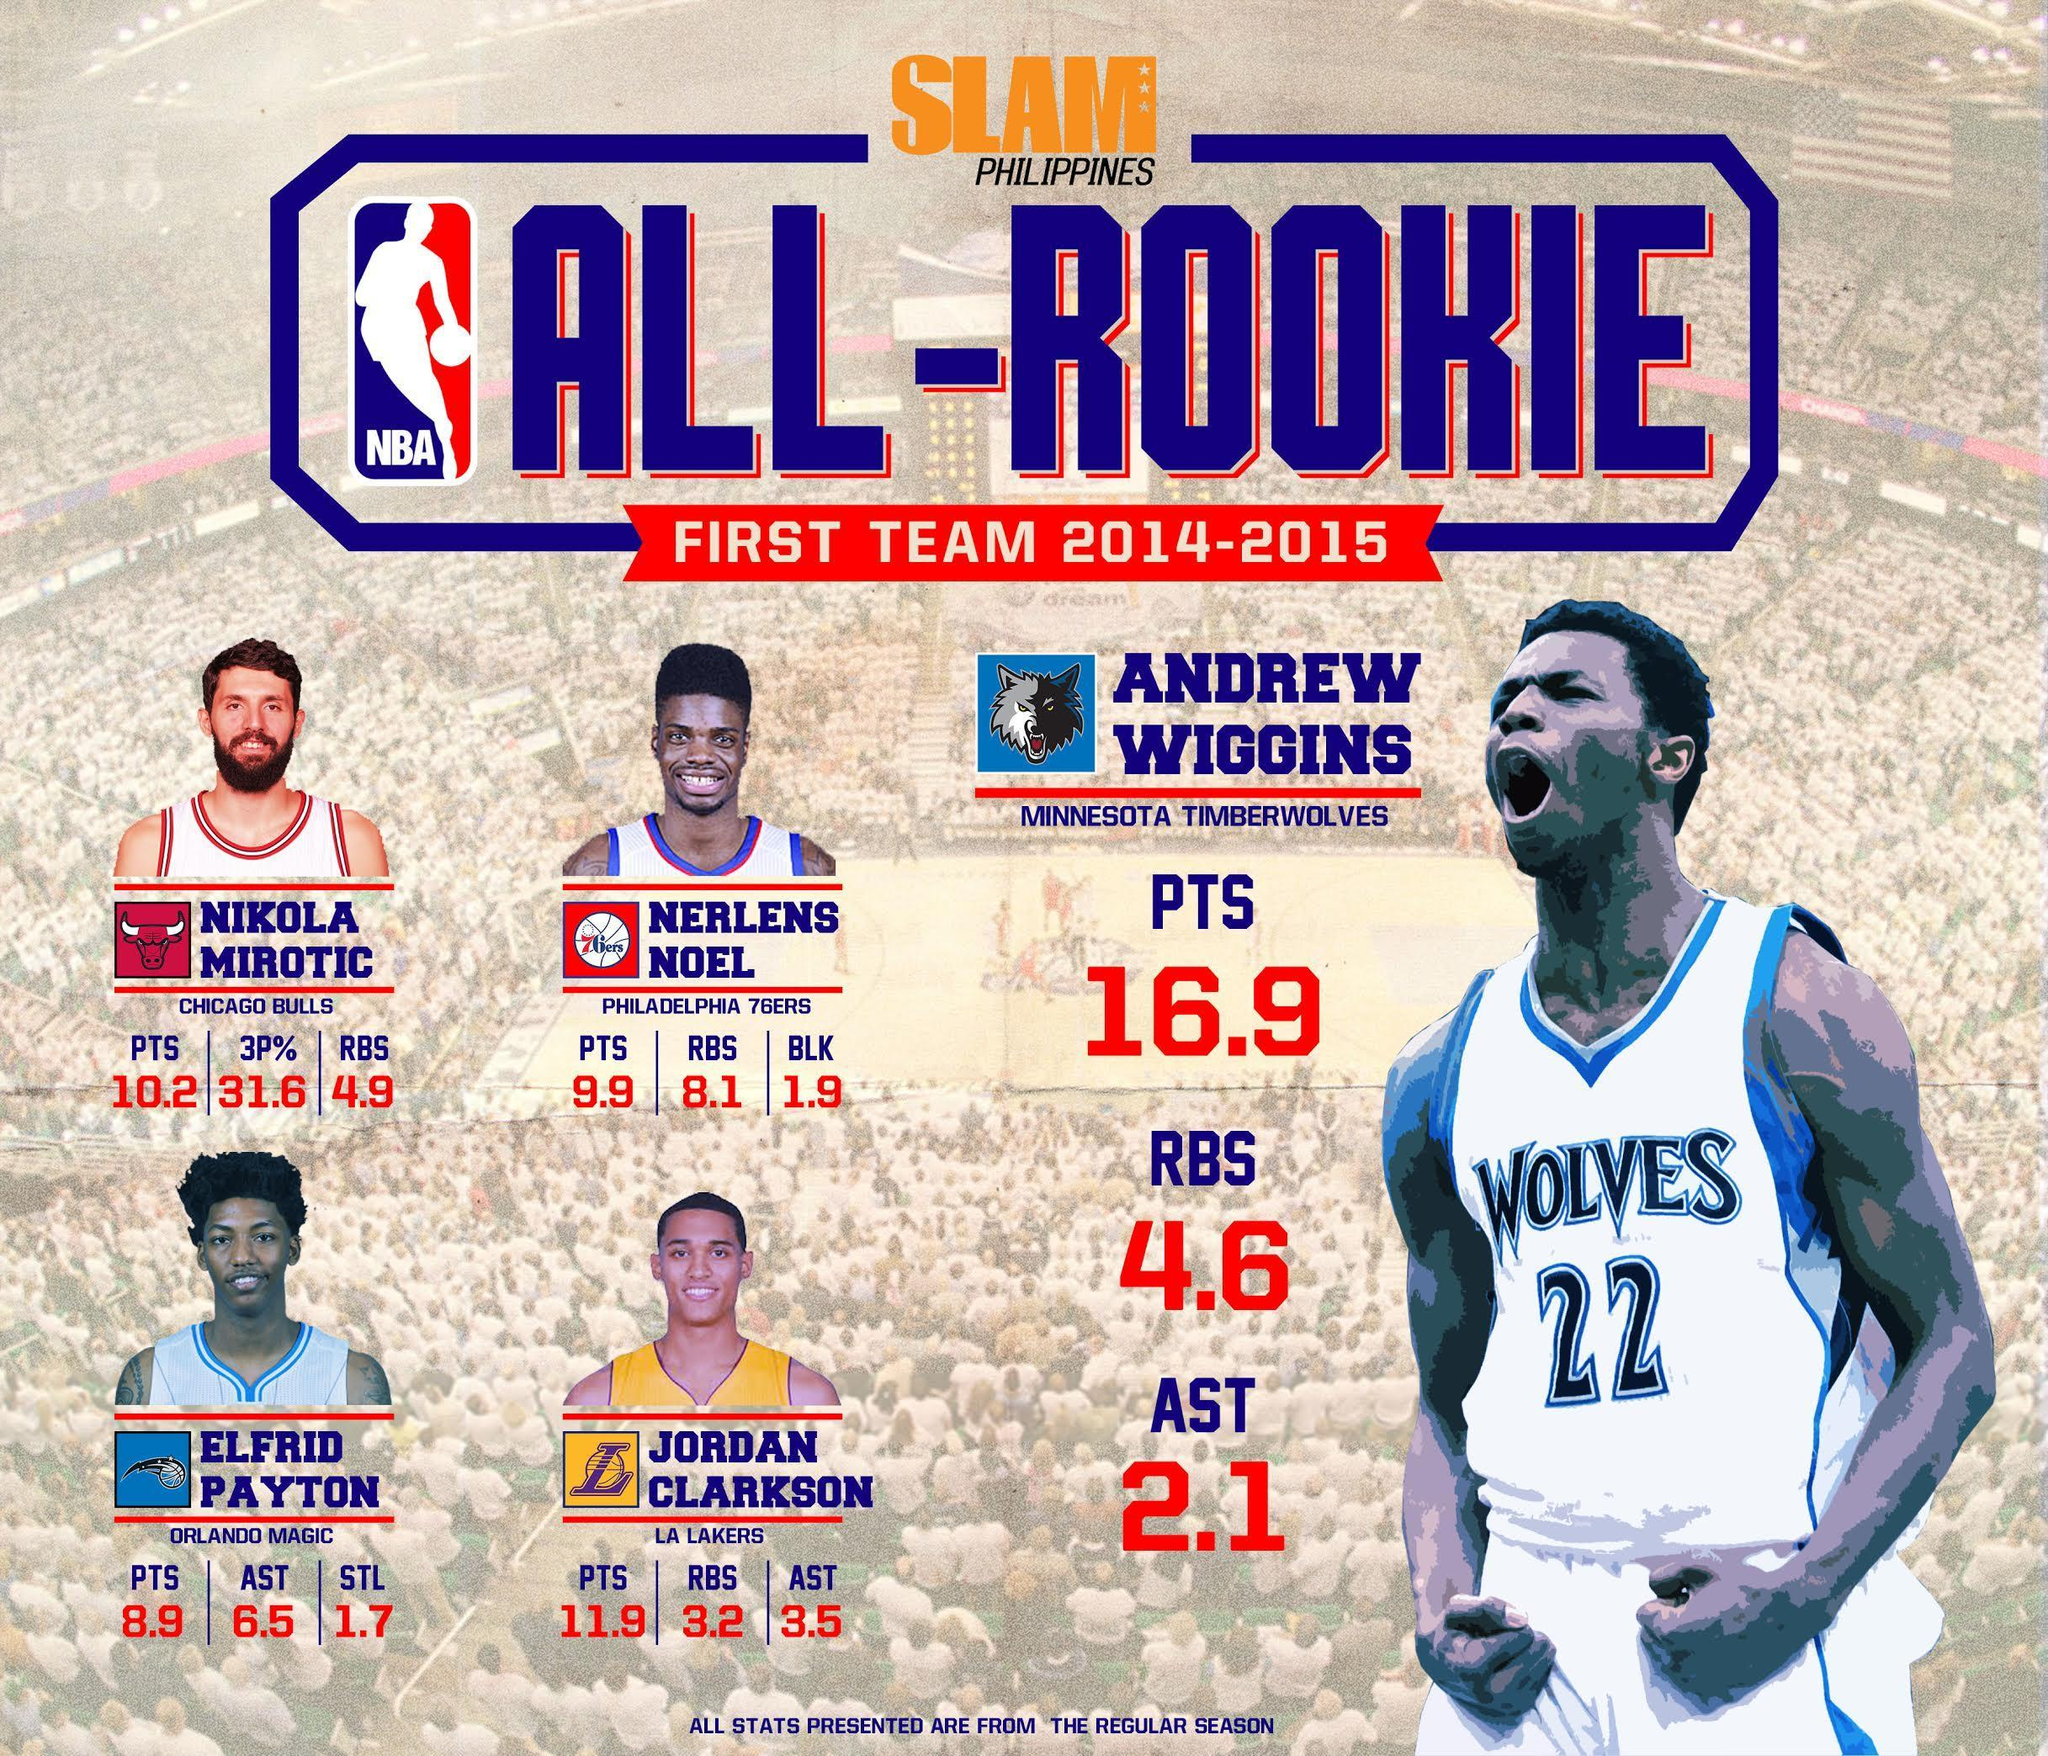Which basketball team does Andrew Wiggins play for during 2014-2015 NBA season?
Answer the question with a short phrase. MINNESOTA TIMBERWOLVES What is the average rebounds by Nerlens Noel during 2014-2015 NBA season? 8.1 Which player has three-point field goal percentage value of 31.6 during 2014-2015 NBA season? NIKOLA MIROTIC What is the average assists by Elfrid Payton during 2014-2015 NBA season? 6.5 What is the jersey number of Andrew Wiggins? 22 What is the average points scored by Nikola Mirotic during 2014-2015 NBA season? 10.2 What is the average rebounds by Jordan Clarkson during 2014-2015 NBA season? 3.2 What is the average points scored by Nerlens Noel during 2014-2015 NBA season? 9.9 Which basketball team does Jordan Clarkson play for during 2014-2015 NBA season? LA LAKERS 